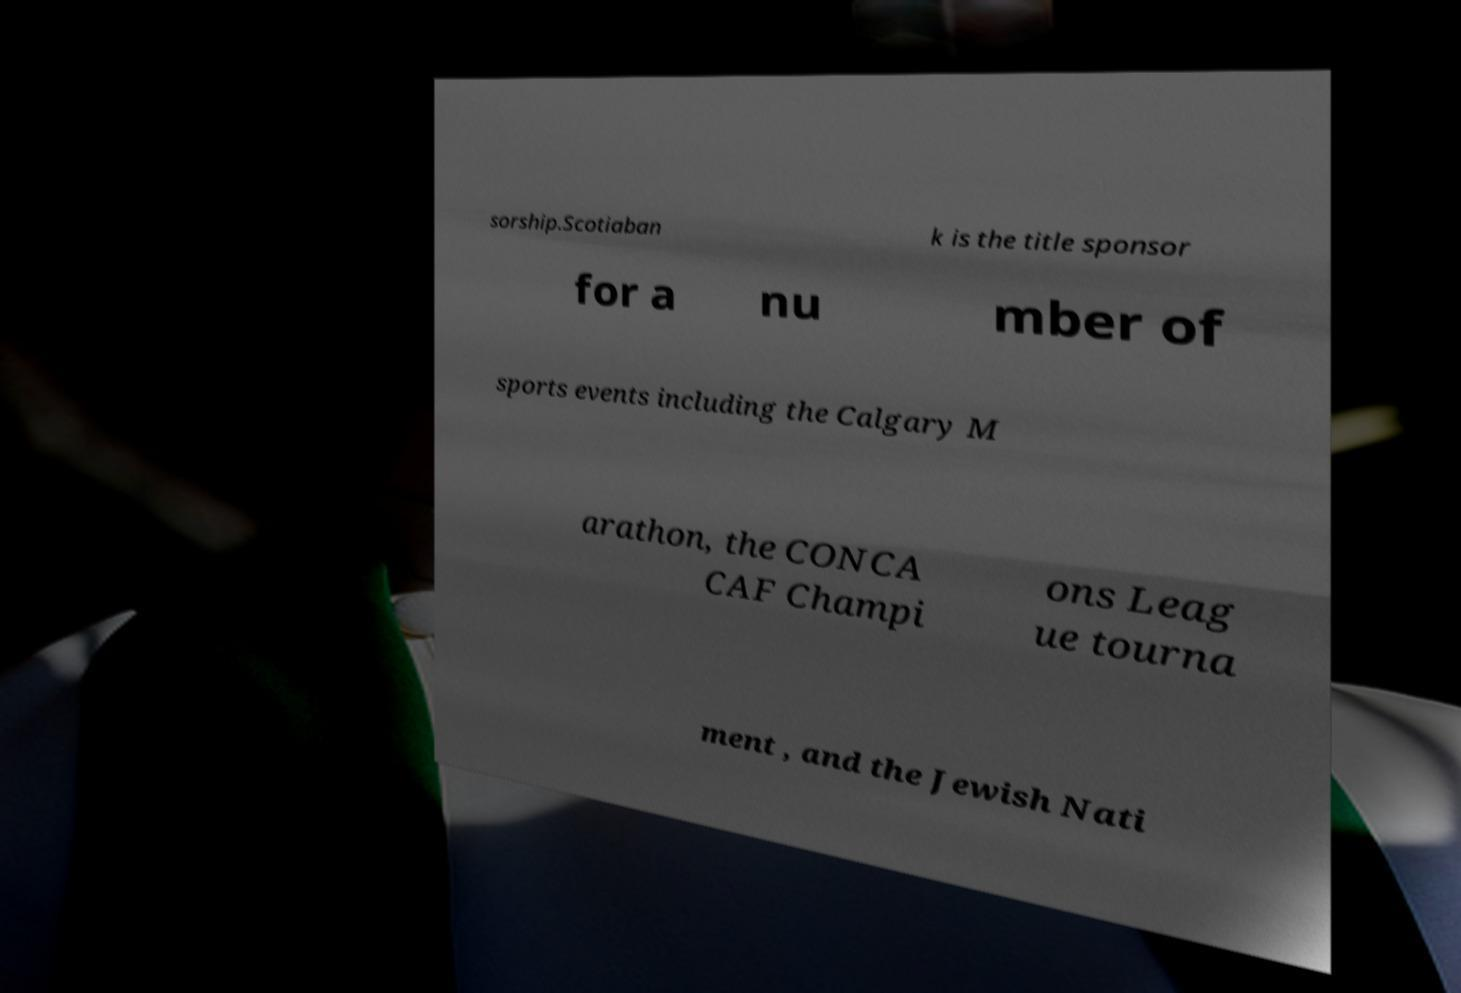Could you assist in decoding the text presented in this image and type it out clearly? sorship.Scotiaban k is the title sponsor for a nu mber of sports events including the Calgary M arathon, the CONCA CAF Champi ons Leag ue tourna ment , and the Jewish Nati 